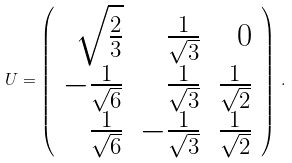<formula> <loc_0><loc_0><loc_500><loc_500>U = \left ( \begin{array} { r r r } \sqrt { \frac { 2 } { 3 } } & \frac { 1 } { \sqrt { 3 } } & 0 \\ - \frac { 1 } { \sqrt { 6 } } & \frac { 1 } { \sqrt { 3 } } & \frac { 1 } { \sqrt { 2 } } \\ \frac { 1 } { \sqrt { 6 } } & - \frac { 1 } { \sqrt { 3 } } & \frac { 1 } { \sqrt { 2 } } \end{array} \right ) \, .</formula> 